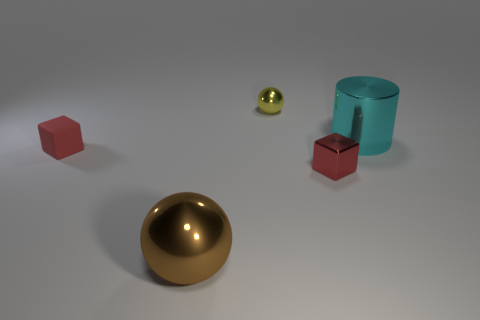Is the rubber cube the same color as the metal cube?
Offer a very short reply. Yes. How many red cubes are there?
Offer a terse response. 2. How big is the block in front of the small matte object?
Give a very brief answer. Small. Is the size of the brown metallic object the same as the yellow shiny object?
Ensure brevity in your answer.  No. What number of things are either red metal things or things that are in front of the large cyan cylinder?
Your answer should be compact. 3. What is the material of the yellow thing?
Offer a very short reply. Metal. Is there anything else of the same color as the tiny rubber thing?
Your answer should be compact. Yes. Does the yellow metal thing have the same shape as the large brown metallic object?
Offer a very short reply. Yes. What is the size of the sphere behind the red cube on the right side of the sphere behind the shiny cylinder?
Offer a very short reply. Small. How many other things are there of the same material as the cyan thing?
Your answer should be very brief. 3. 